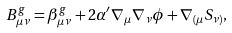<formula> <loc_0><loc_0><loc_500><loc_500>B ^ { g } _ { \mu \nu } = { \beta } ^ { g } _ { \mu \nu } + 2 { \alpha } ^ { \prime } { \nabla } _ { \mu } { \nabla } _ { \nu } \phi + { \nabla } _ { ( \mu } { S } _ { \nu ) } ,</formula> 